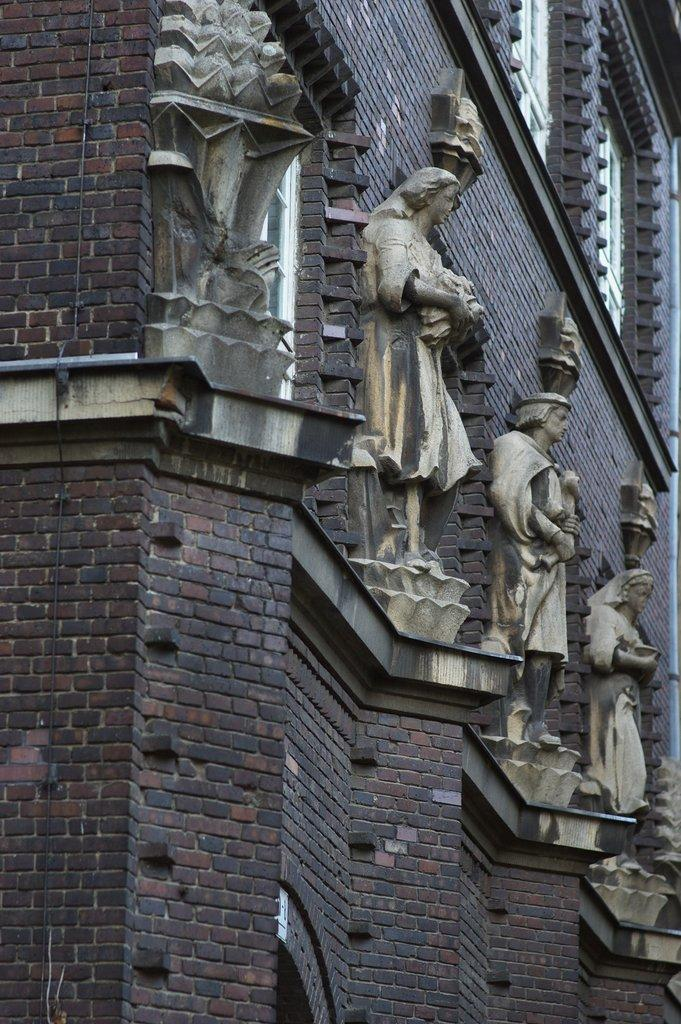What type of structure is present in the image? There is a building in the image. What decorative elements can be seen on the building? There are sculptures on the building. Where are the children playing in the image? There are no children present in the image. What is the afterthought of the sculptures on the building? The image does not provide any information about the afterthought of the sculptures on the building. 